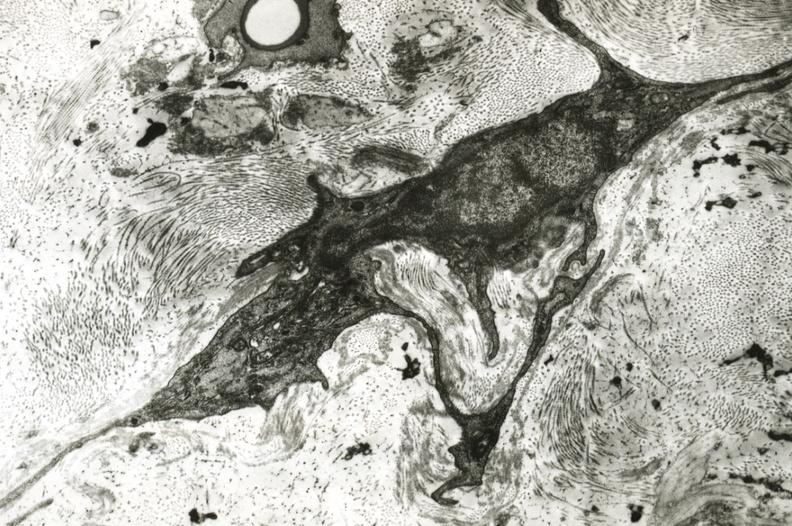what does this image show?
Answer the question using a single word or phrase. Fibroblasts in adventitia of monkey basilar artery 